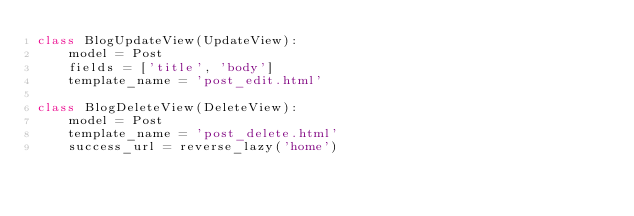Convert code to text. <code><loc_0><loc_0><loc_500><loc_500><_Python_>class BlogUpdateView(UpdateView):
    model = Post
    fields = ['title', 'body']
    template_name = 'post_edit.html'

class BlogDeleteView(DeleteView):
    model = Post
    template_name = 'post_delete.html'
    success_url = reverse_lazy('home')</code> 